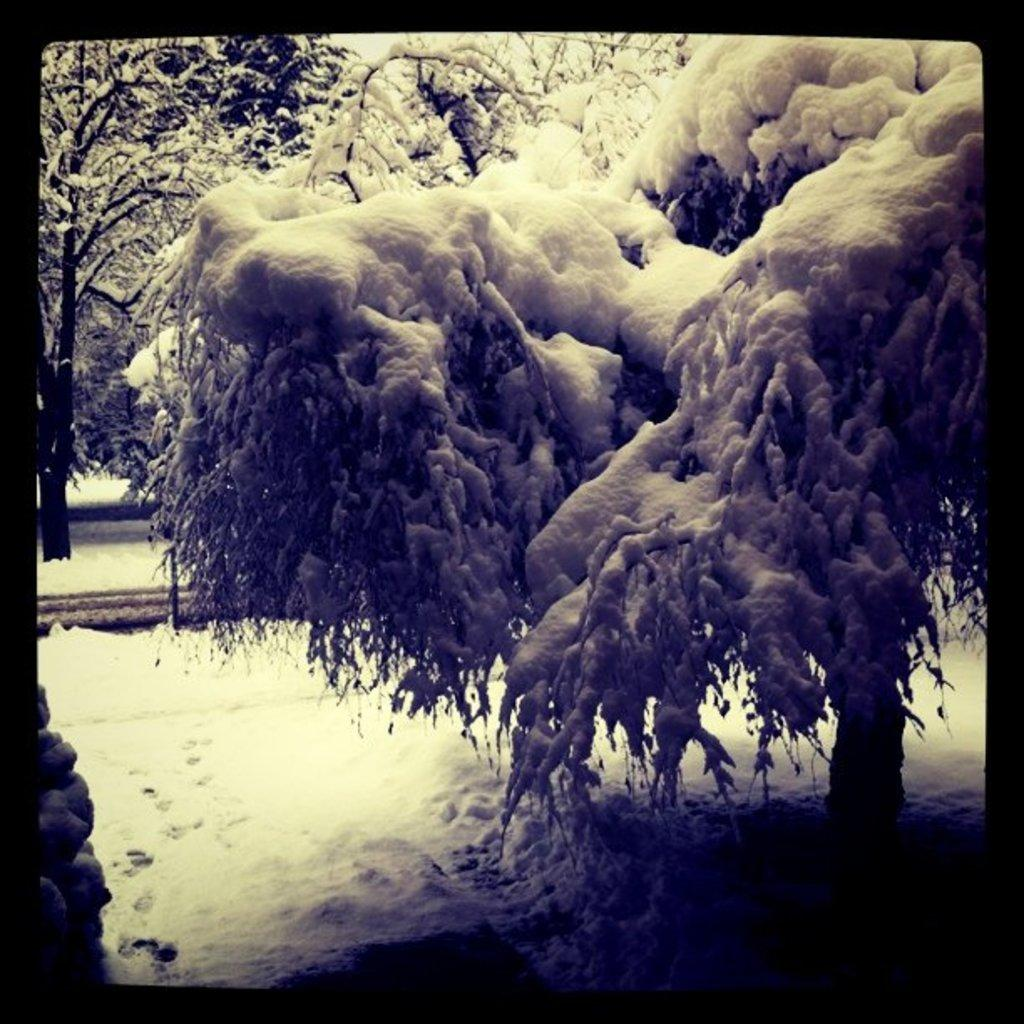What type of vegetation can be seen in the image? There are trees in the image. What is covering the trees in the image? There is snow on the trees. What type of coat is the tree wearing in the image? Trees do not wear coats; the image shows snow covering the trees. Is the tree swimming in the image? Trees do not swim; the image shows snow covering the trees. 